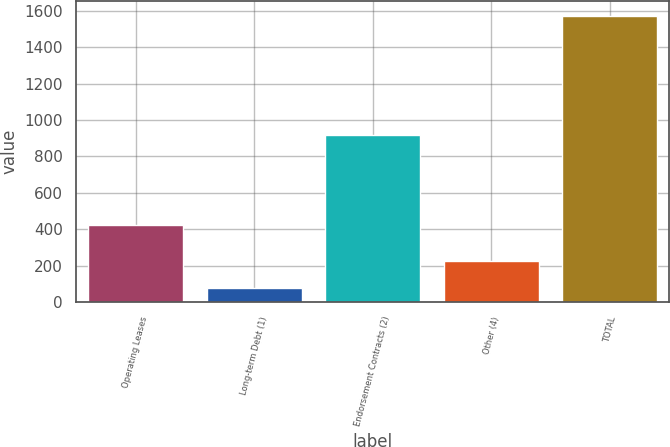Convert chart to OTSL. <chart><loc_0><loc_0><loc_500><loc_500><bar_chart><fcel>Operating Leases<fcel>Long-term Debt (1)<fcel>Endorsement Contracts (2)<fcel>Other (4)<fcel>TOTAL<nl><fcel>423<fcel>77<fcel>919<fcel>226.6<fcel>1573<nl></chart> 